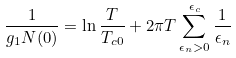Convert formula to latex. <formula><loc_0><loc_0><loc_500><loc_500>\frac { 1 } { g _ { 1 } N ( 0 ) } = \ln \frac { T } { T _ { c 0 } } + 2 \pi T \sum _ { \epsilon _ { n } > 0 } ^ { \epsilon _ { c } } \frac { 1 } { \epsilon _ { n } }</formula> 